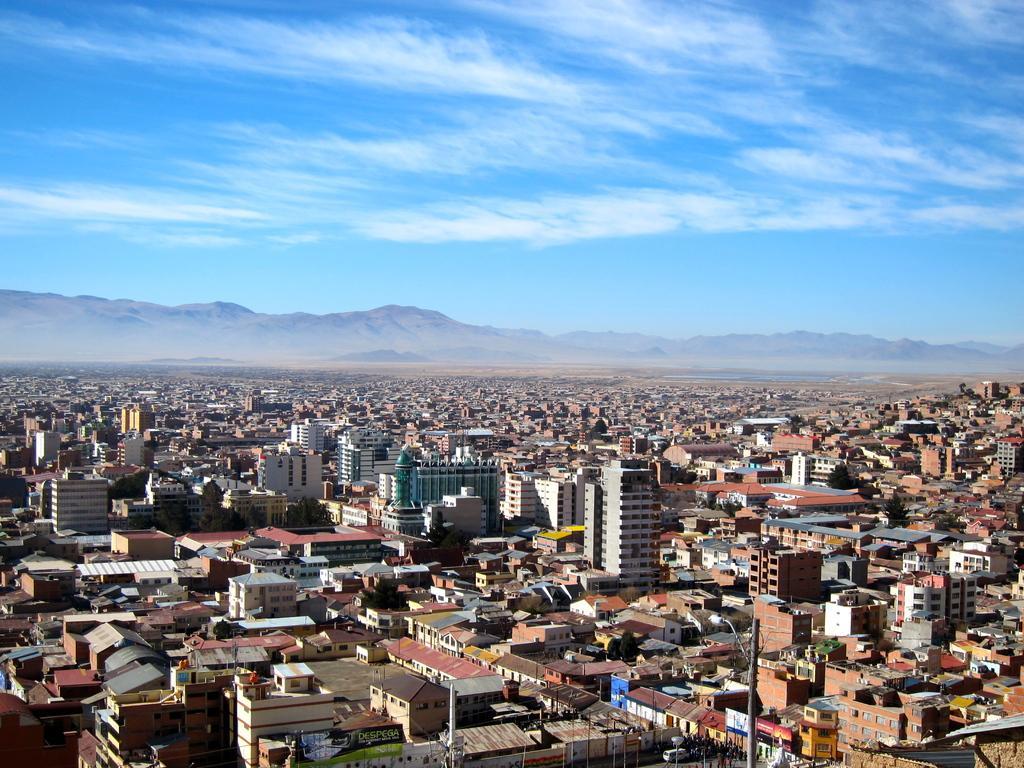Please provide a concise description of this image. In this image we can see so many buildings, there are some trees, poles, lights, mountains and boards with some text on it, in the background we can see the sky with clouds. 